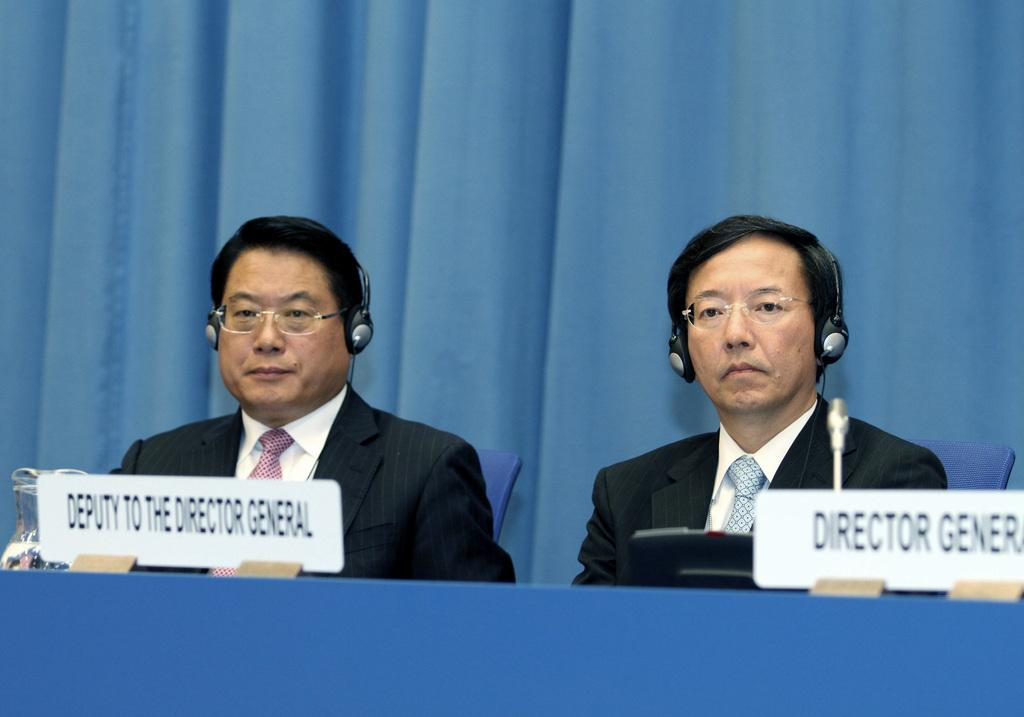<image>
Write a terse but informative summary of the picture. A director general and his deputy sit beind their respective signs at a table and are wearing headphones. 